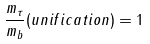Convert formula to latex. <formula><loc_0><loc_0><loc_500><loc_500>\frac { m _ { \tau } } { m _ { b } } ( u n i f i c a t i o n ) = 1</formula> 